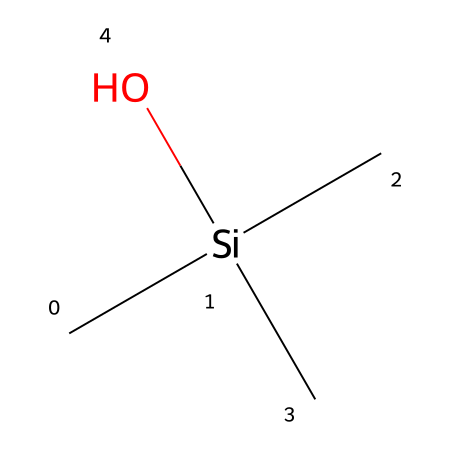What is the name of this chemical? The provided SMILES representation corresponds to trimethylsilanol, where "C[Si](C)(C)O" indicates a silicon atom bonded to three methyl groups and one hydroxyl group.
Answer: trimethylsilanol How many carbon atoms are present? Counting from the SMILES, there are three carbon atoms represented as "C" and one intrinsic carbon from the silicon bond, totaling four.
Answer: four What is the oxidation state of silicon in this compound? In the structure, silicon is bonded to three carbon groups and one hydroxyl group, which indicates it is in a +4 oxidation state, as silicon typically forms four bonds.
Answer: +4 What functional group is present in trimethylsilanol? The hydroxyl group (-OH) indicated in the SMILES ("O") is the defining feature of alcohols, making it a functional group in this compound.
Answer: hydroxyl group How many hydrogen atoms are attached to silicon in trimethylsilanol? Each methyl group (3 total) has 3 hydrogen atoms, giving 9 hydrogens. The hydroxyl group adds one more, totaling 10 attached hydrogen atoms, but there are no hydrogens directly attached to the silicon in this arrangement.
Answer: zero What type of silane is trimethylsilanol classified as? Trimethylsilanol falls under the category of silanol, which is characterized by the presence of hydroxyl groups bound to silicon atoms.
Answer: silanol What type of bonding does trimethylsilanol predominantly exhibit? It primarily exhibits covalent bonding, as the atoms are sharing electrons to form molecular structures among silicon, carbon, and oxygen.
Answer: covalent 